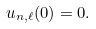<formula> <loc_0><loc_0><loc_500><loc_500>u _ { n , \ell } ( 0 ) = 0 .</formula> 